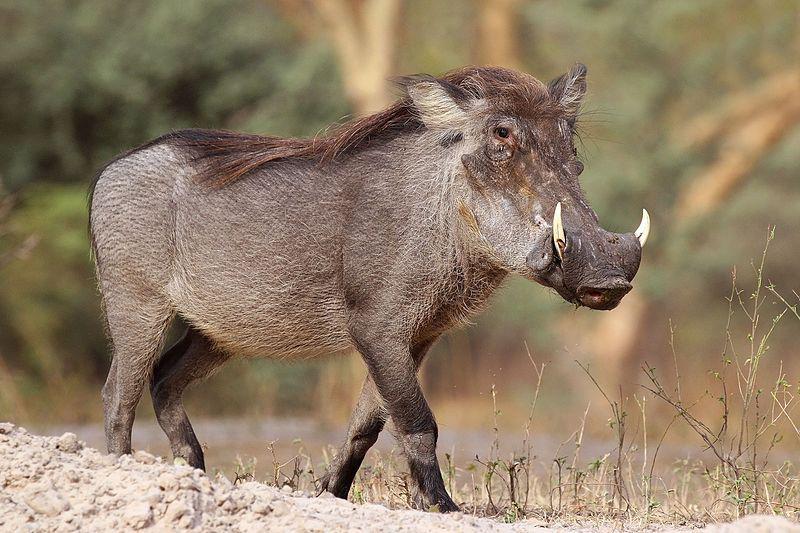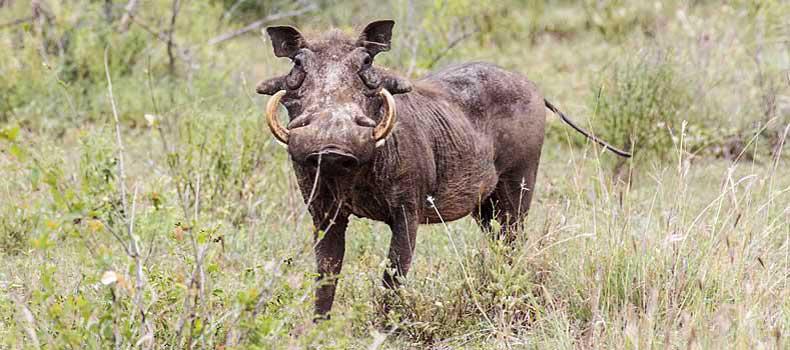The first image is the image on the left, the second image is the image on the right. Given the left and right images, does the statement "More than one warthog is present in one of the images." hold true? Answer yes or no. No. 